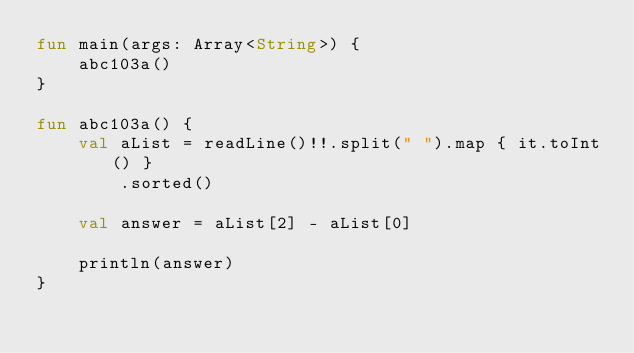Convert code to text. <code><loc_0><loc_0><loc_500><loc_500><_Kotlin_>fun main(args: Array<String>) {
    abc103a()
}

fun abc103a() {
    val aList = readLine()!!.split(" ").map { it.toInt() }
        .sorted()

    val answer = aList[2] - aList[0]

    println(answer)
}
</code> 